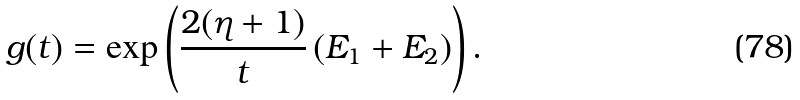Convert formula to latex. <formula><loc_0><loc_0><loc_500><loc_500>g ( t ) = \exp \left ( \frac { 2 ( \eta + 1 ) } { t } \left ( E _ { 1 } + E _ { 2 } \right ) \right ) .</formula> 